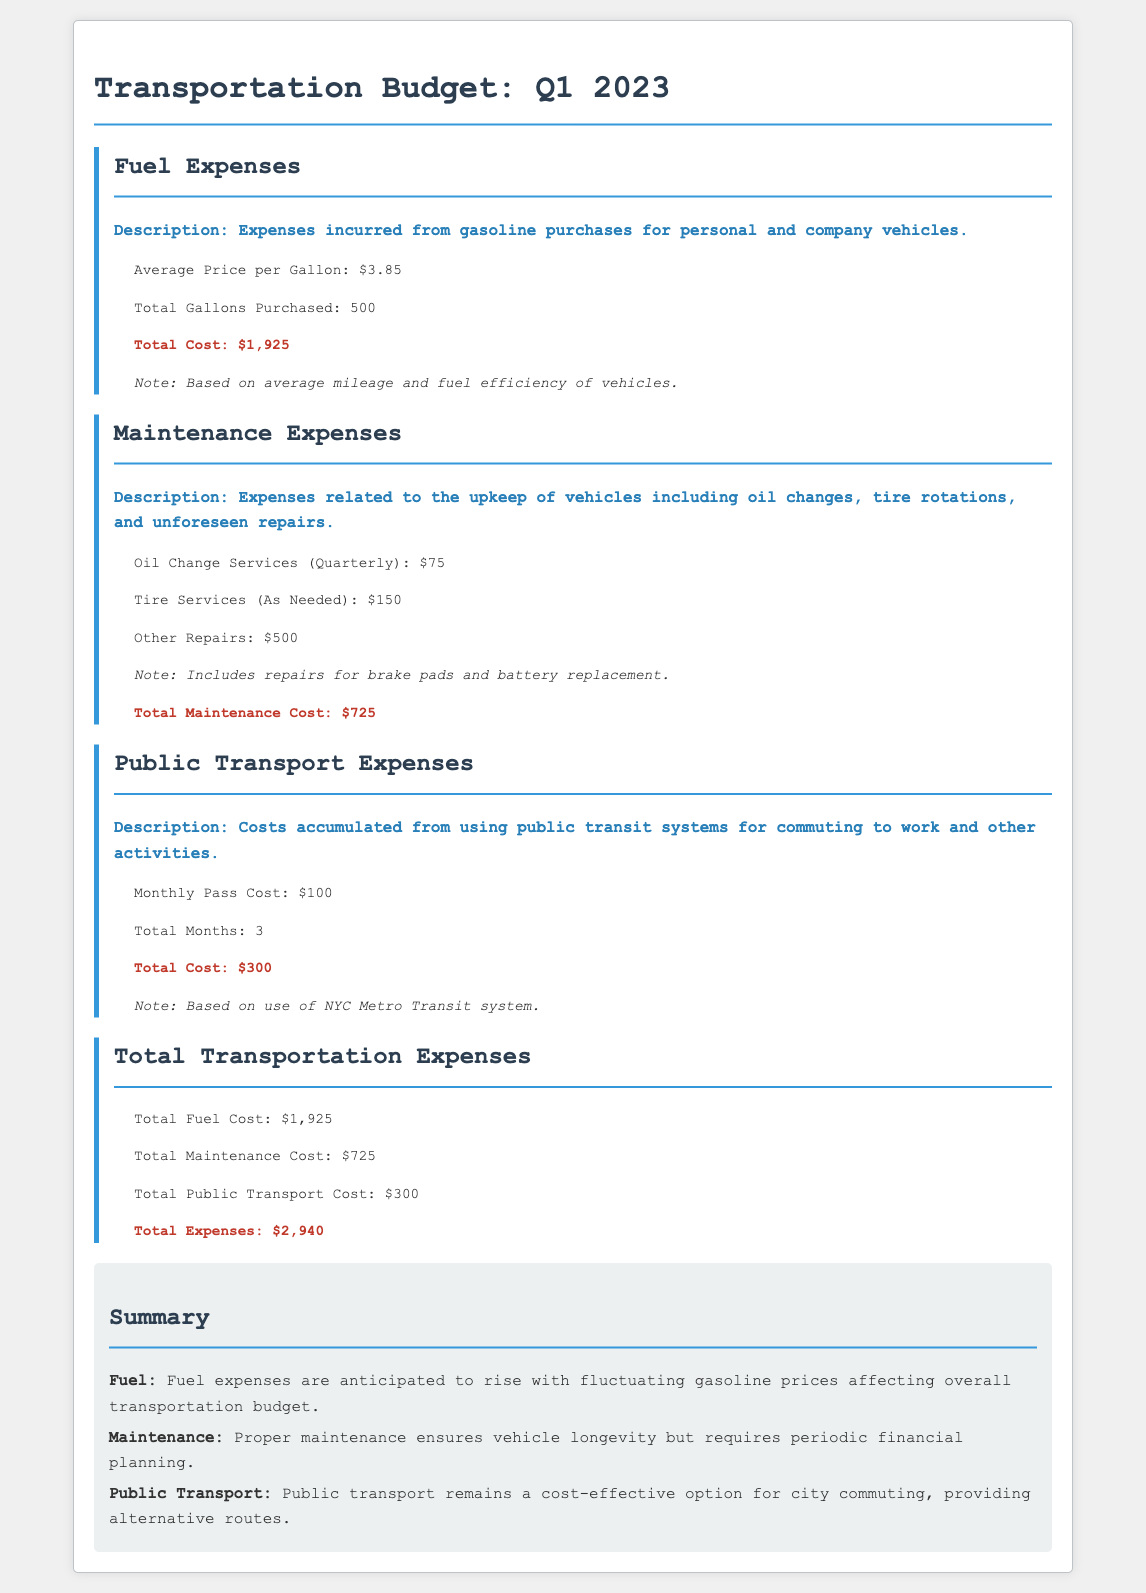What is the total fuel cost? The total fuel cost is explicitly stated in the document under the fuel expenses section, which totals $1,925.
Answer: $1,925 What is the average price per gallon of fuel? The average price per gallon of fuel is mentioned in the fuel expenses section, which is $3.85.
Answer: $3.85 What are the total maintenance costs? The total maintenance costs can be found in the maintenance expenses section, summing up to $725.
Answer: $725 What is the monthly pass cost for public transport? The monthly pass cost for public transport is specified in the public transport expenses section, which is $100.
Answer: $100 What is the total transportation expense? The total transportation expense is the sum of all expense categories, detailed in the total transportation expenses section, totaling $2,940.
Answer: $2,940 How many gallons of fuel were purchased? The document states that a total of 500 gallons of fuel were purchased under the fuel expenses section.
Answer: 500 What type of transit system is referenced for public transport costs? The document specifies that the New York City Metro Transit system is utilized for calculating public transport costs.
Answer: NYC Metro Transit system What is included in maintenance expenses? The maintenance expenses include oil change services, tire services, and unforeseen repairs, as detailed in the maintenance section.
Answer: Oil changes, tire services, repairs What does the summary say about fuel expenses? The summary provides insights related to the expectation of rising fuel expenses due to fluctuating gasoline prices, found in the summary section.
Answer: Rising gasoline prices 